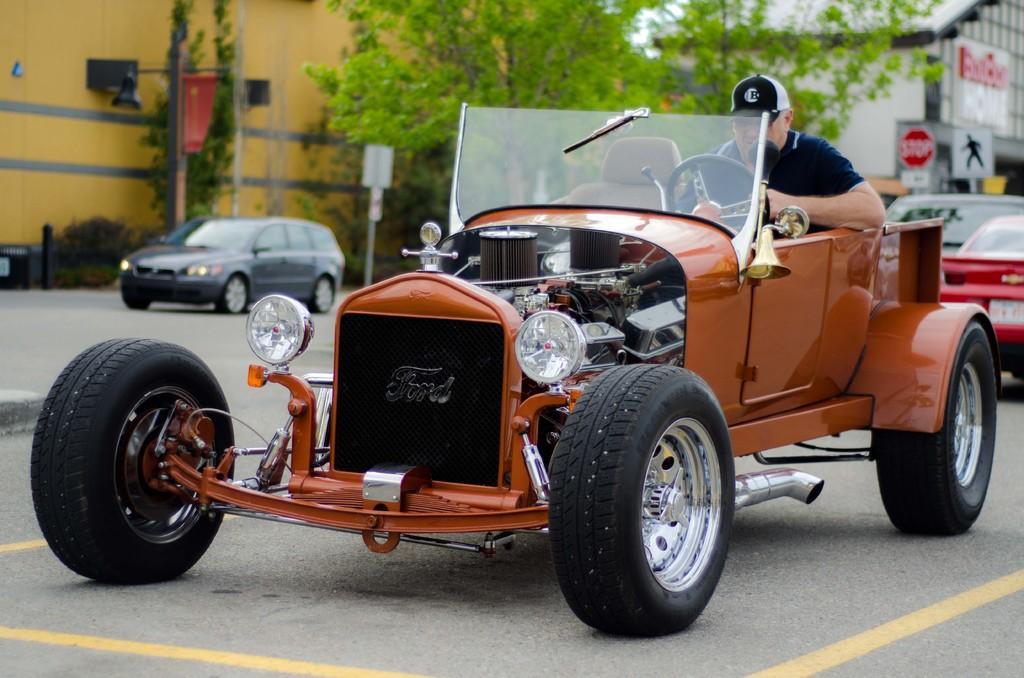Could you give a brief overview of what you see in this image? In this image, we can see person in the vehicle and in the background, there are some other vehicles and we can see boards, trees, poles, buildings and a light. At the bottom, there is a road. 